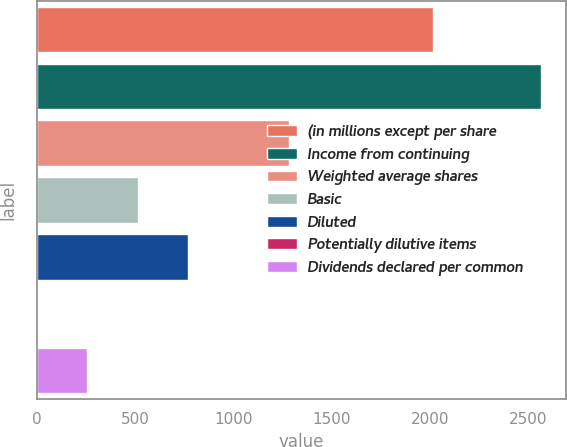Convert chart. <chart><loc_0><loc_0><loc_500><loc_500><bar_chart><fcel>(in millions except per share<fcel>Income from continuing<fcel>Weighted average shares<fcel>Basic<fcel>Diluted<fcel>Potentially dilutive items<fcel>Dividends declared per common<nl><fcel>2016<fcel>2567<fcel>1284.5<fcel>515<fcel>771.5<fcel>2<fcel>258.5<nl></chart> 